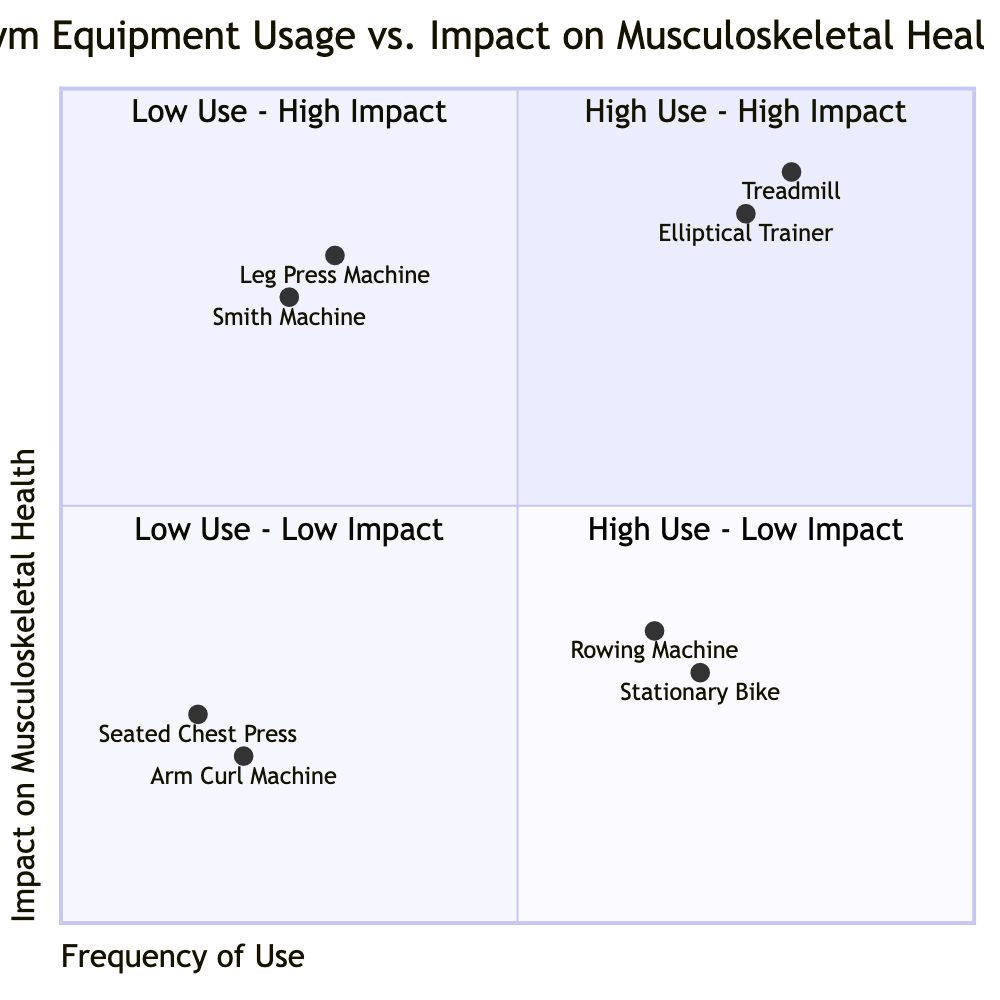What equipment is in the High Use - High Impact quadrant? The High Use - High Impact quadrant includes equipment that is both frequently used and beneficial for musculoskeletal health. According to the data, the items listed are the Treadmill and the Elliptical Trainer.
Answer: Treadmill, Elliptical Trainer Which equipment has Low Use and High Impact? The Low Use - High Impact quadrant contains equipment that is not frequently used but has significant benefits for musculoskeletal health. The Leg Press Machine and Smith Machine fit this description based on the data provided.
Answer: Leg Press Machine, Smith Machine How many types of gym equipment are categorized as Low Use - Low Impact? In the Low Use - Low Impact quadrant, there are two types of gym equipment listed: the Arm Curl Machine and the Seated Chest Press. Therefore, the count is 2.
Answer: 2 What is the impact level of the Rowing Machine? The data indicates that the Rowing Machine falls into the High Use - Low Impact quadrant. According to the chart, its impact level is Low.
Answer: Low Which equipment has the highest musculoskeletal health impact? The two pieces of equipment with the highest impact on musculoskeletal health, both listed in the High Use - High Impact quadrant, are the Treadmill and the Elliptical Trainer. However, since a single answer is requested, we can consider the Treadmill as a notable example with High impact.
Answer: Treadmill Which quadrant has the equipment with the lowest frequency of use? The Low Use - Low Impact quadrant contains equipment that has the lowest frequency of use according to the data, which corresponds to the Arm Curl Machine and Seated Chest Press. This quadrant represents the equipment with Low use and Low impact.
Answer: Low Use - Low Impact How many pieces of equipment are in the High Use - Low Impact quadrant? The High Use - Low Impact quadrant includes two specific types of gym equipment: the Stationary Bike and Rowing Machine. Therefore, the total count is 2.
Answer: 2 What equipment has High Use and Low Impact? According to the High Use - Low Impact quadrant, the equipment categorized as High Use but Low Impact includes the Stationary Bike and the Rowing Machine.
Answer: Stationary Bike, Rowing Machine 